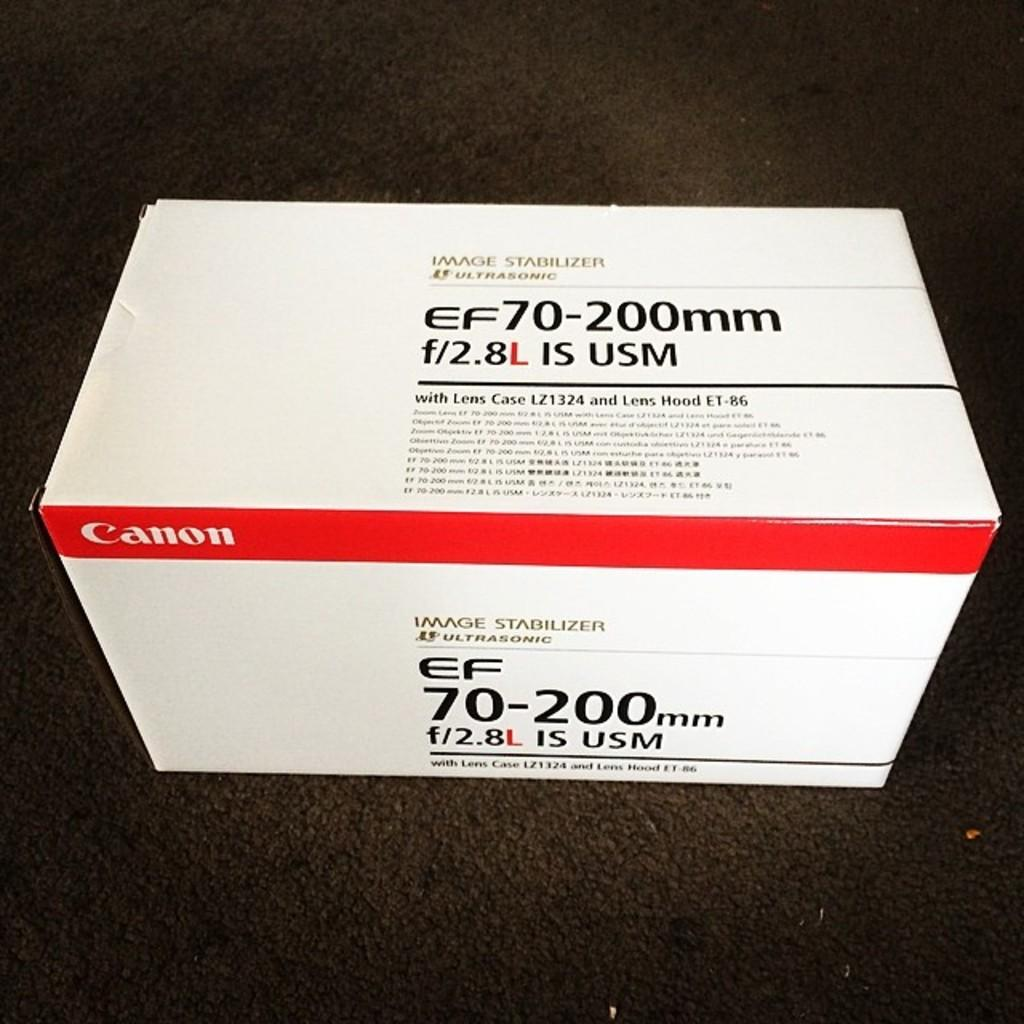<image>
Give a short and clear explanation of the subsequent image. a Canon box has an image stabilizer in it, and sits on the floor 